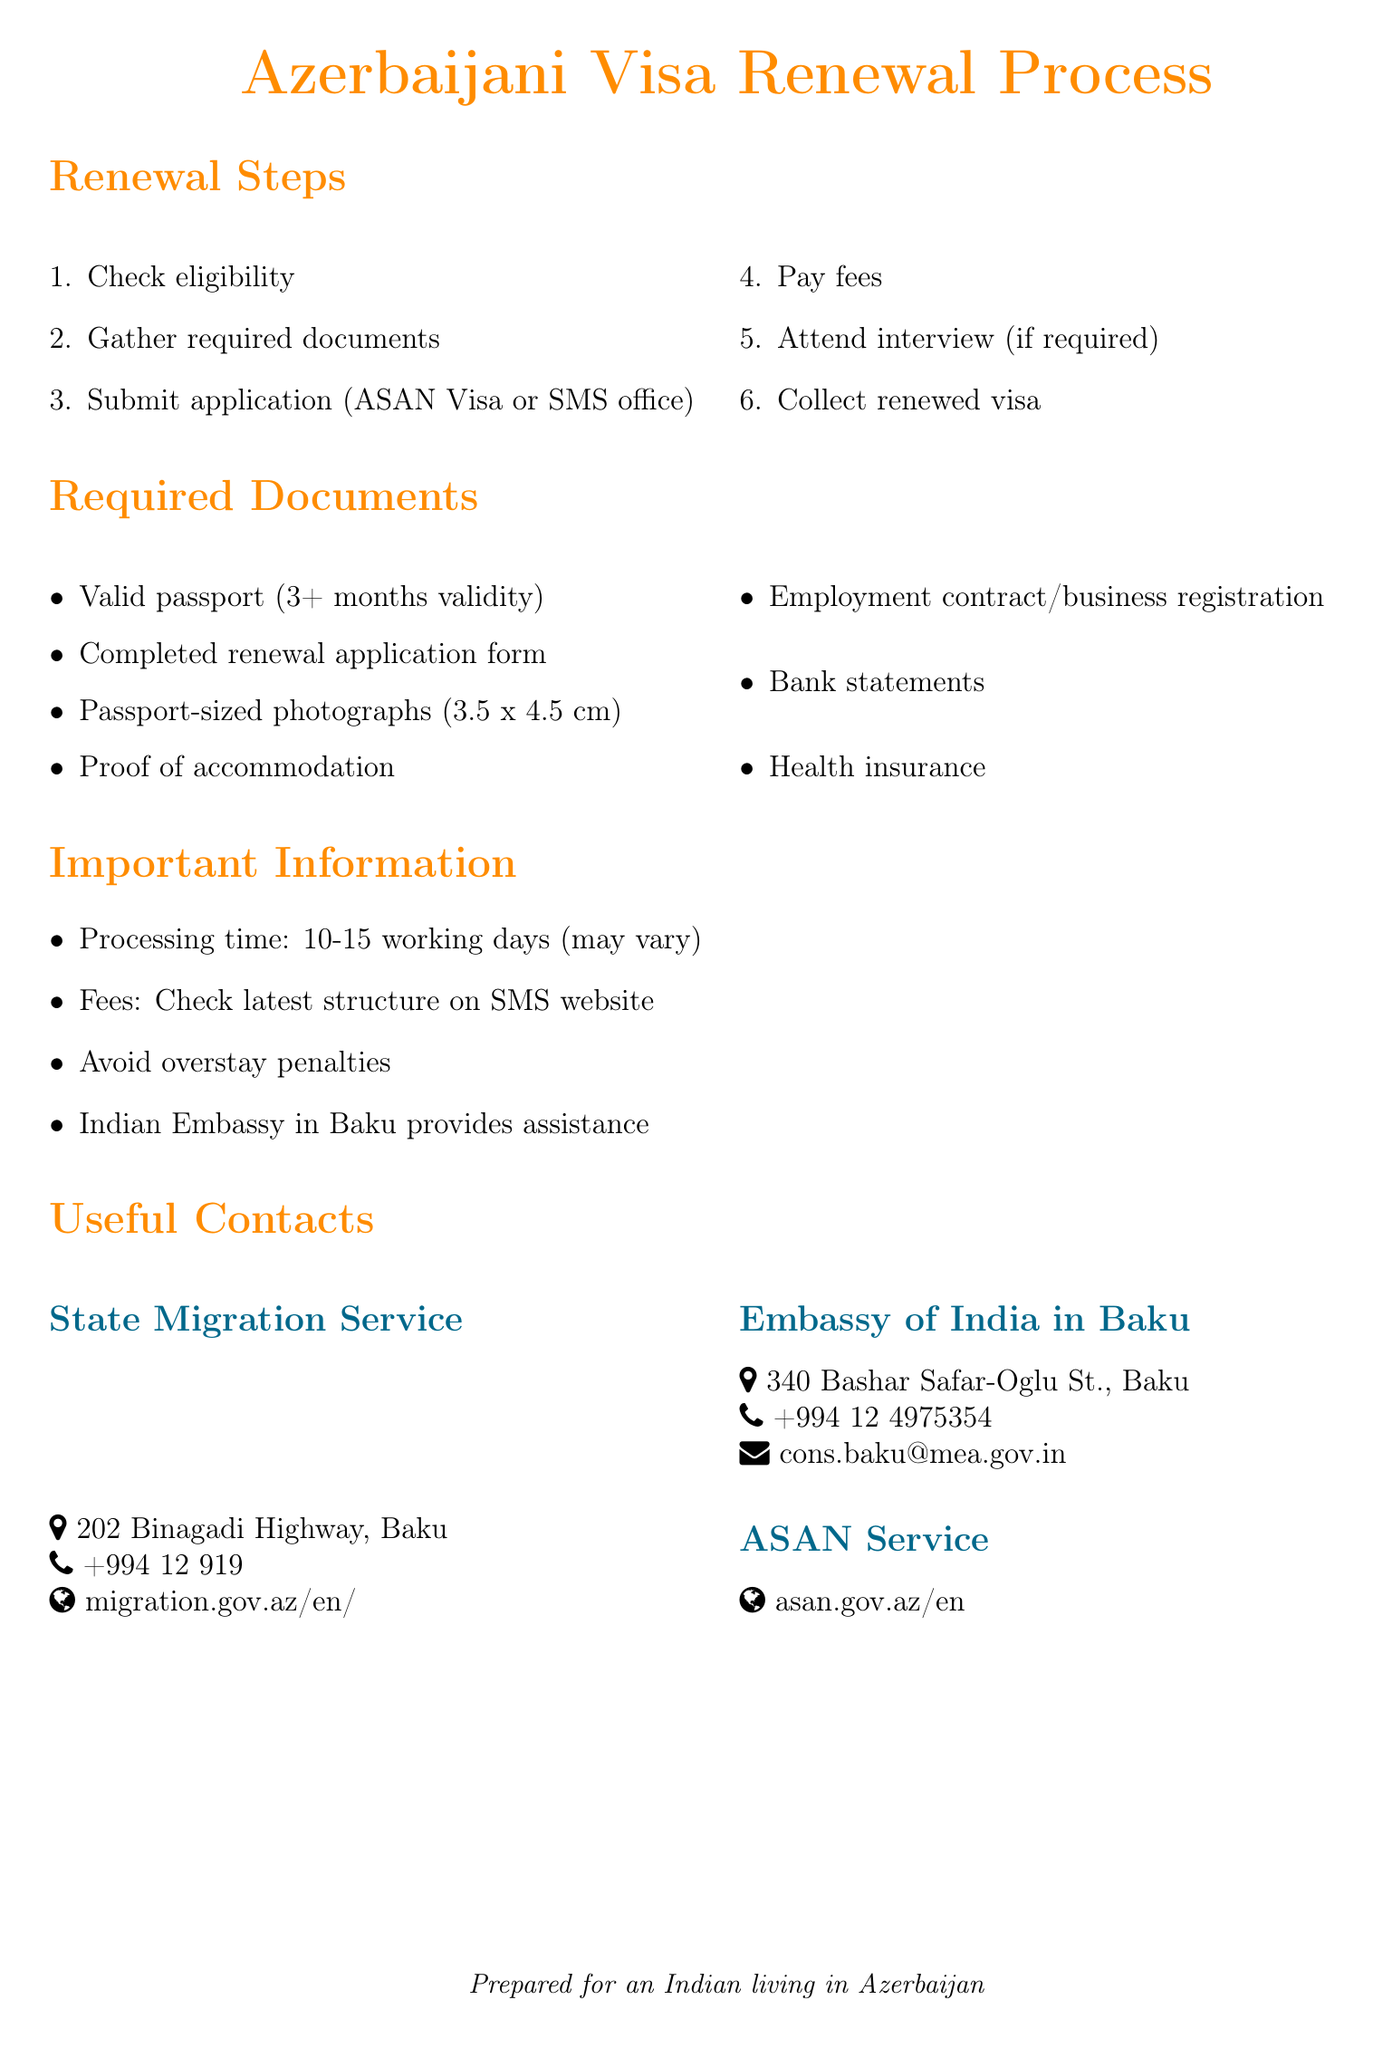What is the first step in the visa renewal process? The first step outlined in the document is to "Check eligibility."
Answer: Check eligibility What is the processing time for visa renewal? The document states that visa renewal typically takes "10-15 working days."
Answer: 10-15 working days What document is required to show accommodation? The document mentions "Proof of accommodation" as a required document.
Answer: Proof of accommodation Which service can assist with online visa applications? The document refers to "ASAN Service" for online visa applications and renewals.
Answer: ASAN Service What should the passport validity be for renewal? The document specifies that the passport must be valid for "at least 3 months beyond the intended stay."
Answer: at least 3 months beyond the intended stay What happens if you overstay your visa? The document warns to "Ensure timely renewal to avoid fines and potential deportation."
Answer: fines and potential deportation What payment methods can be used for visa renewal fees? The document states that fees can be paid "through designated banks or online payment systems."
Answer: designated banks or online payment systems Where is the State Migration Service located? The document provides the address as "202 Binagadi Highway, Binagadi district, Baku, AZ1114."
Answer: 202 Binagadi Highway, Binagadi district, Baku, AZ1114 Who can provide support during the visa renewal process? The document notes that "The Embassy of India in Baku" can provide guidance and support.
Answer: The Embassy of India in Baku 